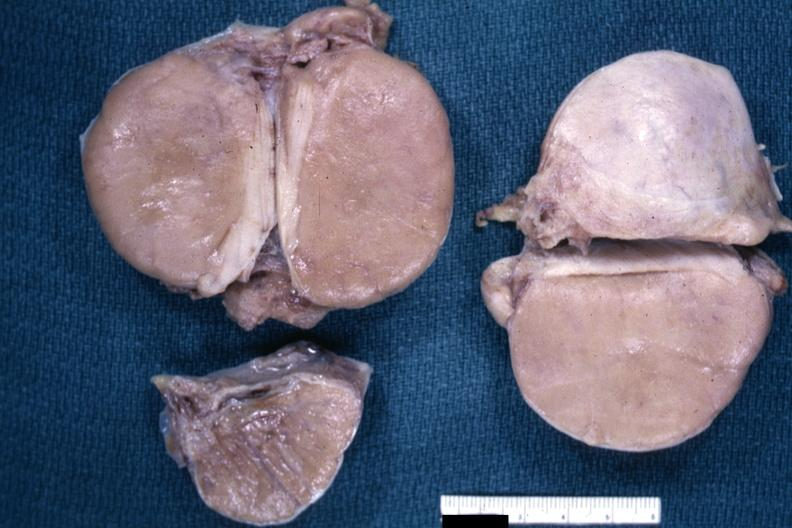does this image show fixed tissue i think discrete lesion well shown?
Answer the question using a single word or phrase. Yes 